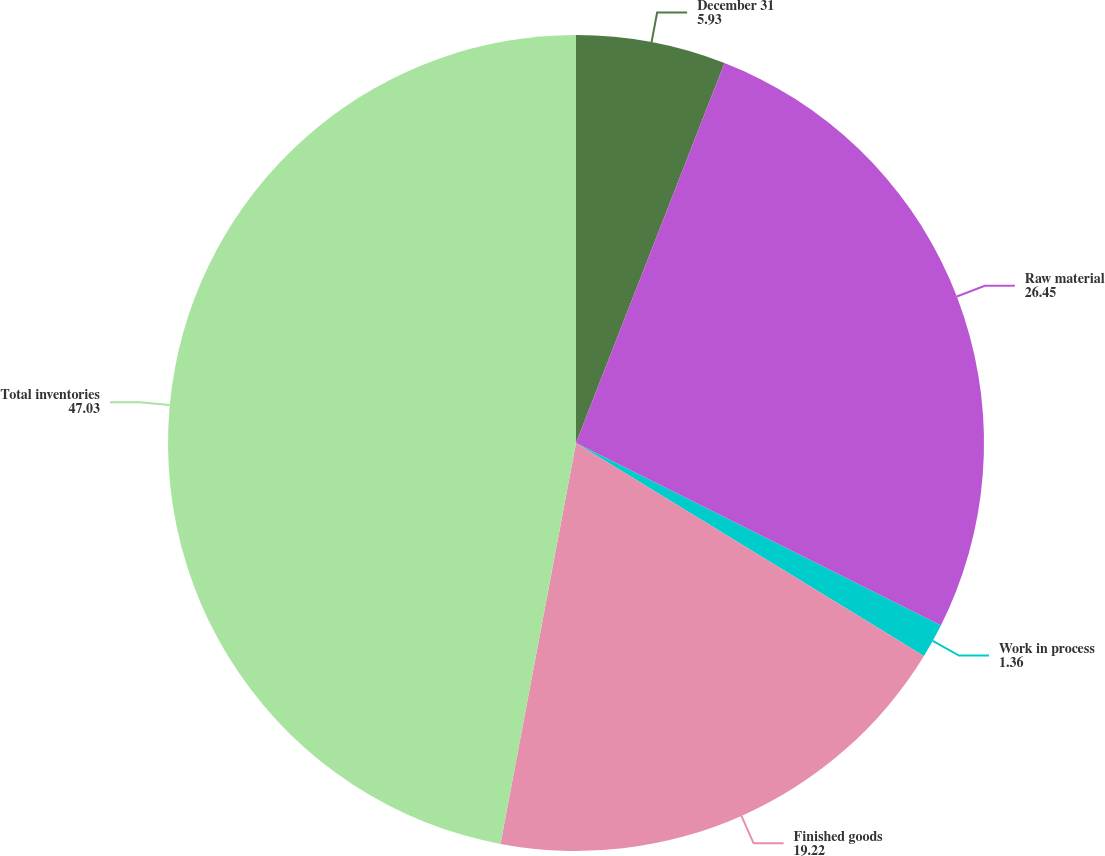Convert chart to OTSL. <chart><loc_0><loc_0><loc_500><loc_500><pie_chart><fcel>December 31<fcel>Raw material<fcel>Work in process<fcel>Finished goods<fcel>Total inventories<nl><fcel>5.93%<fcel>26.45%<fcel>1.36%<fcel>19.22%<fcel>47.03%<nl></chart> 